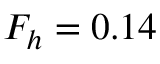<formula> <loc_0><loc_0><loc_500><loc_500>F _ { h } = 0 . 1 4</formula> 